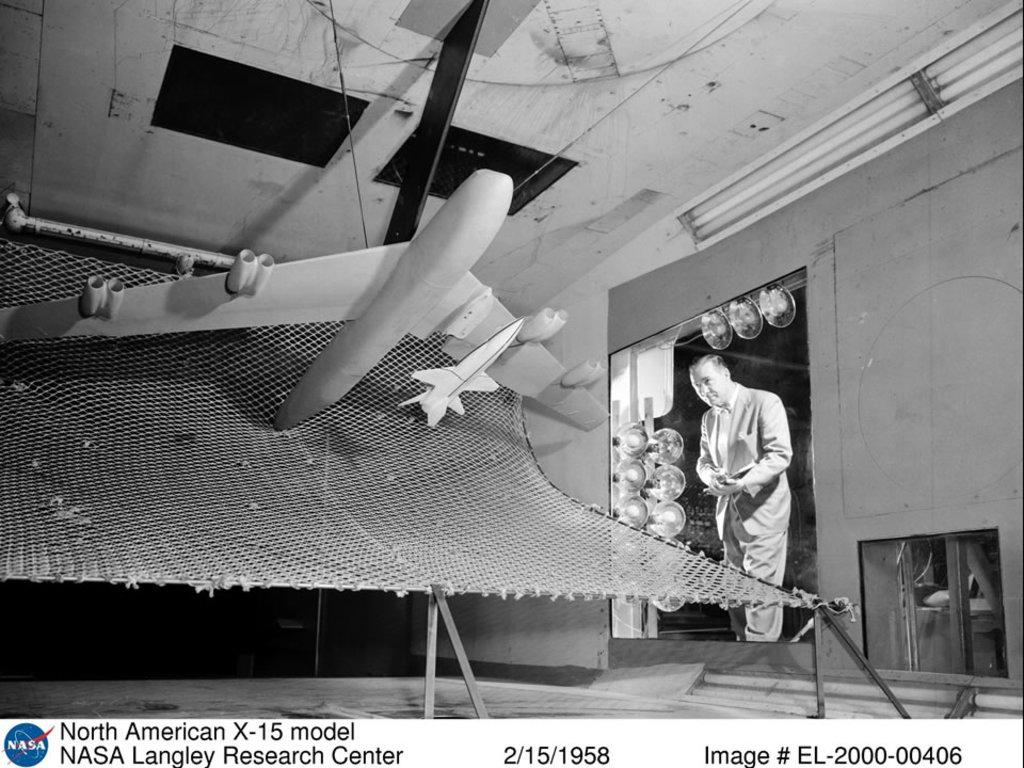<image>
Provide a brief description of the given image. A black and white photo of a man looking at a model RX-15 is identiified as being taken at the NASA Langley Research Center on 02/15/1958. 